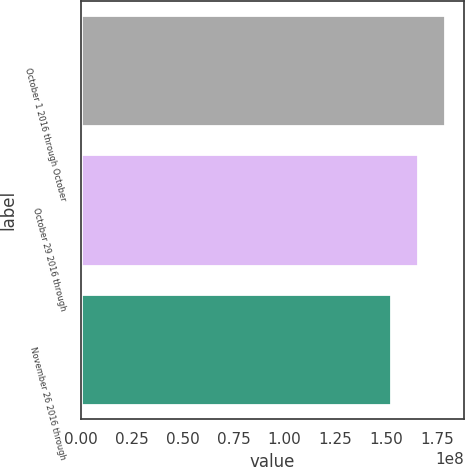Convert chart to OTSL. <chart><loc_0><loc_0><loc_500><loc_500><bar_chart><fcel>October 1 2016 through October<fcel>October 29 2016 through<fcel>November 26 2016 through<nl><fcel>1.78901e+08<fcel>1.65557e+08<fcel>1.52355e+08<nl></chart> 